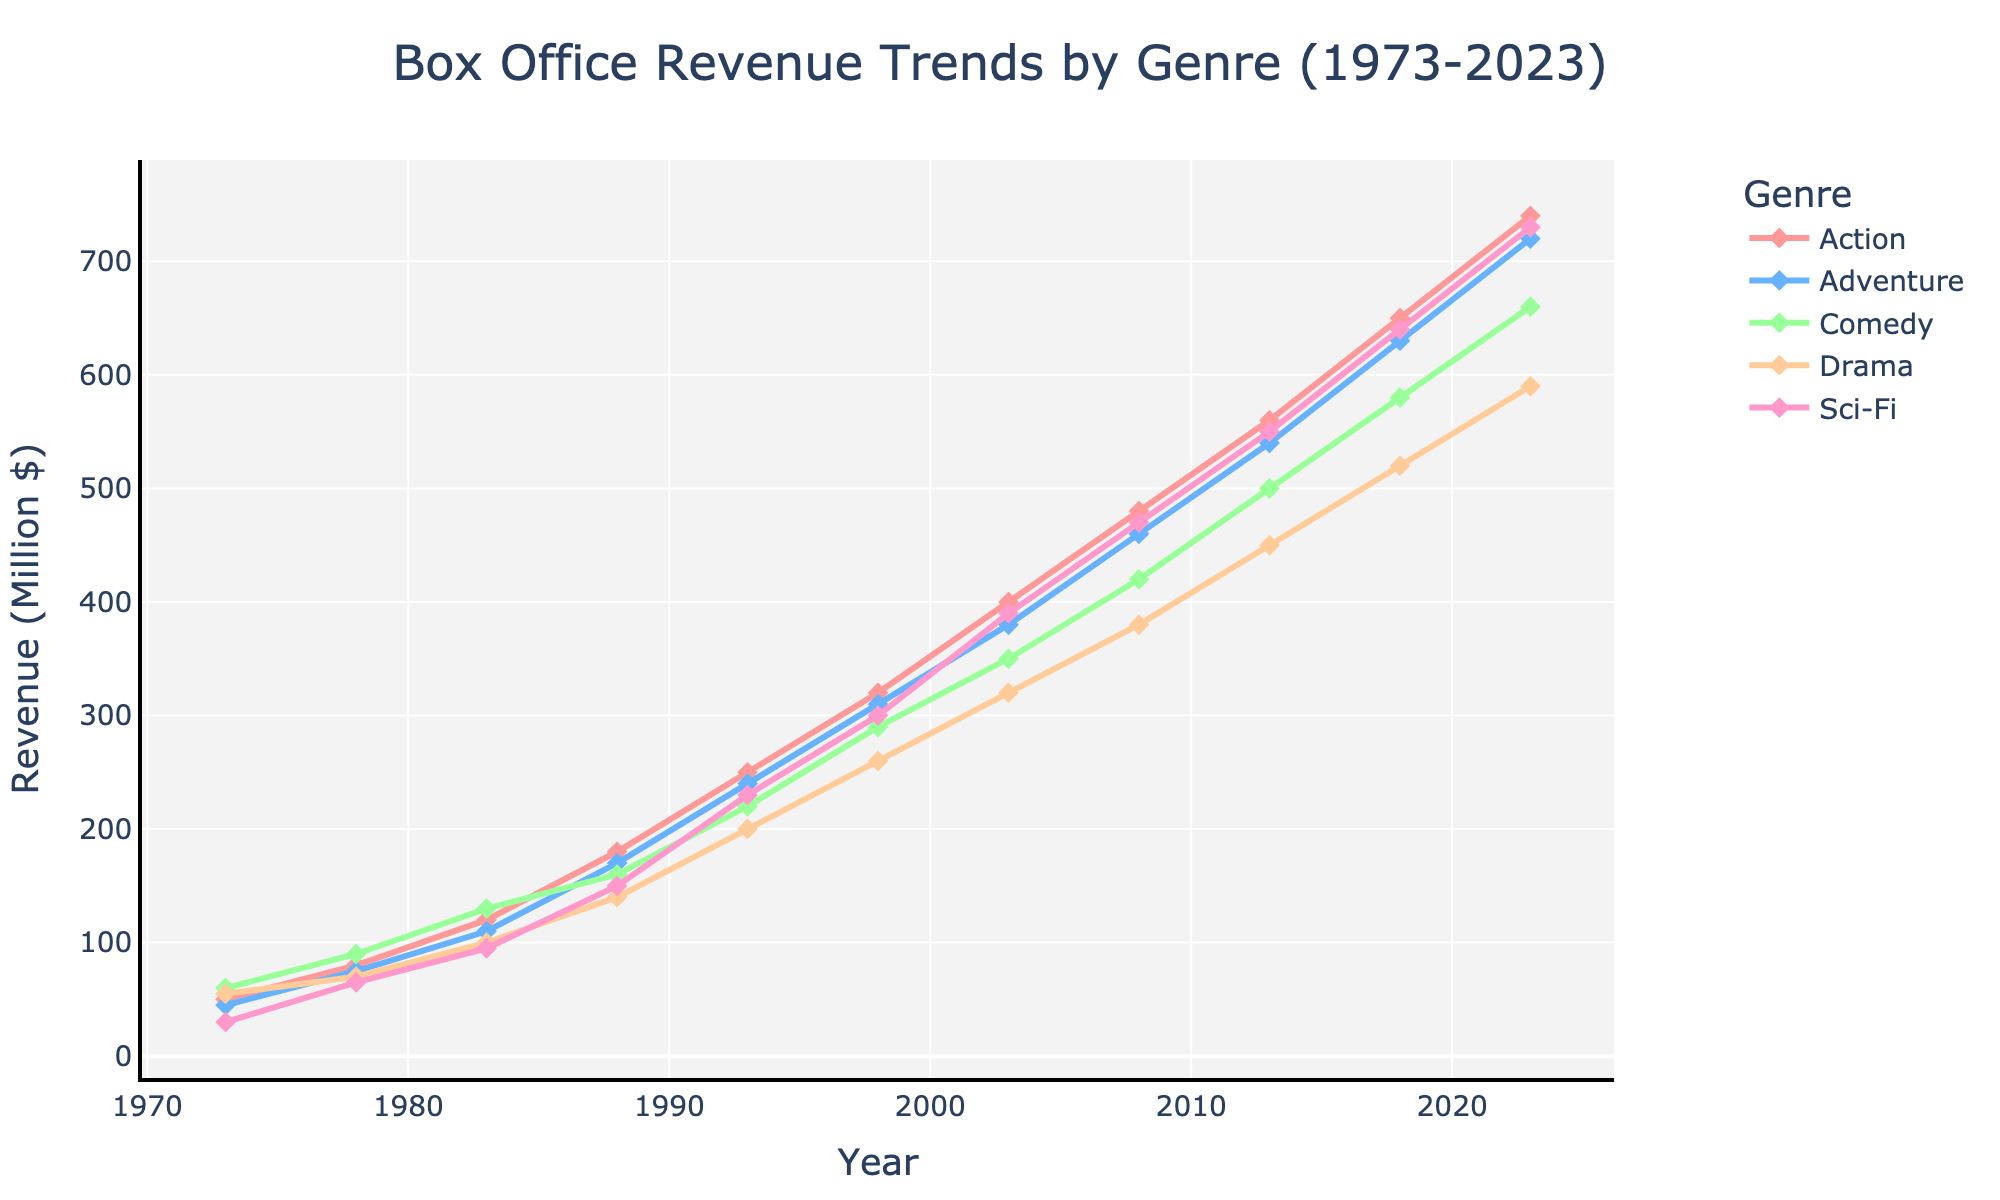What genre saw the highest box office revenue in 2023? First, identify the year 2023 on the x-axis of the line chart. Then, compare the y-values for each genre. Sci-Fi has the highest point with the value of 730.
Answer: Sci-Fi How did the revenue for Comedy films in 1988 compare to Drama films in the same year? Locate the year 1988 on the x-axis. For Comedy, the revenue is at 160, and for Drama, it is 140. Comedy revenue is higher than Drama revenue by 20 million dollars.
Answer: Comedy is higher What is the general trend of Action genre revenue from 1973 to 2023? Observe the line representing the Action genre from the start in 1973 to the end in 2023. The line shows a consistent upward trend, indicating rising revenue.
Answer: Increasing Which genre had the sharpest increase in revenue between 2018 and 2023? Look at the lines between the years 2018 and 2023. Calculate the differences in revenue for each genre: Action (90), Adventure (90), Comedy (80), Drama (70), and Sci-Fi (90). Action, Adventure, and Sci-Fi have the greatest increase of 90 million dollars.
Answer: Action, Adventure, and Sci-Fi What is the approximate average box office revenue for Adventure films across all years in the chart? Sum the y-values for Adventure (45 + 75 + 110 + 170 + 240 + 310 + 380 + 460 + 540 + 630 + 720) which equals 3670. Divide this by the number of data points (11): 3670 / 11 ≈ 333.64.
Answer: 333.64 Which year had the closest box office revenue for Comedy and Drama genres? Identify points where Comedy and Drama lines are closely aligned. Notably, in 1988, Comedy revenue is 160, and Drama is 140, which is the closest difference of 20 million dollars.
Answer: 1988 Compare the growth rates of Sci-Fi and Action from 2008 to 2013. Calculate the increase for Sci-Fi: 550 - 470 = 80. For Action: 560 - 480 = 80. The growth rates for Sci-Fi and Action from 2008 to 2013 are the same.
Answer: Equal In which period did the Adventure genre see the greatest increase in revenue over a 5-year span? Analyze each 5-year span for Adventure: 1983-1988 (110-170=60), 1988-1993 (170-240=70), 1993-1998 (240-310=70), 1998-2003 (310-380=70), 2003-2008 (380-460=80), 2008-2013 (460-540=80), 2013-2018 (540-630=90), 2018-2023 (630-720=90). The largest increase was in the periods 2013-2018 and 2018-2023 (each 90).
Answer: 2013-2018 and 2018-2023 